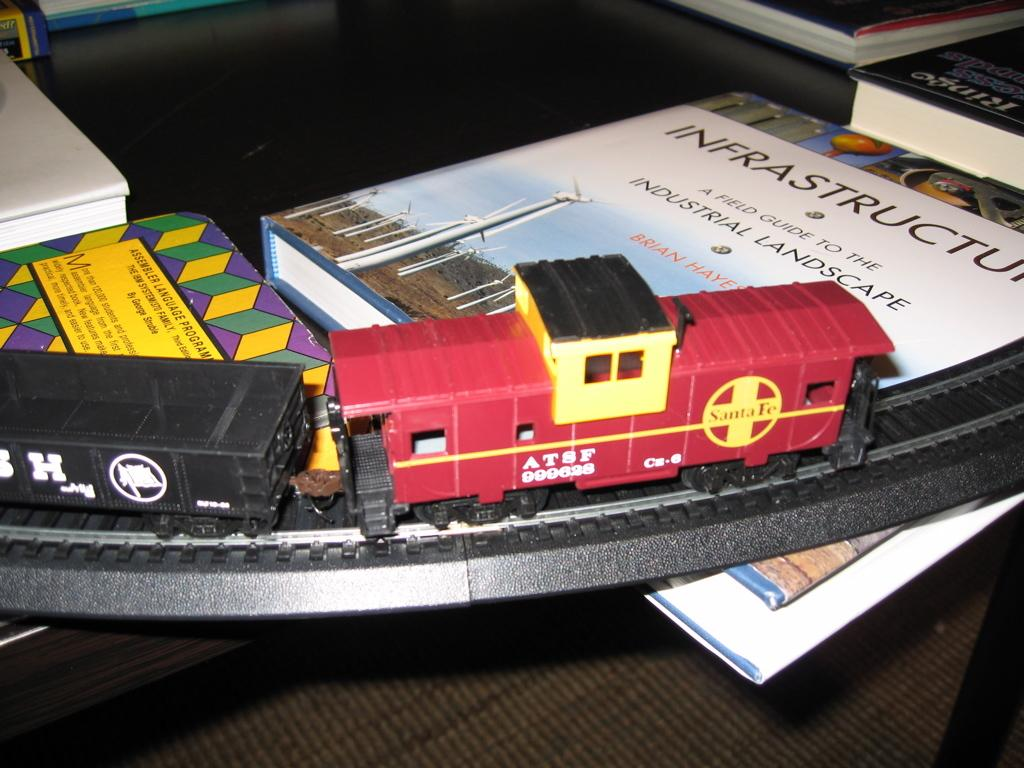<image>
Render a clear and concise summary of the photo. A model train sits on a track above an Infrastructure book. 